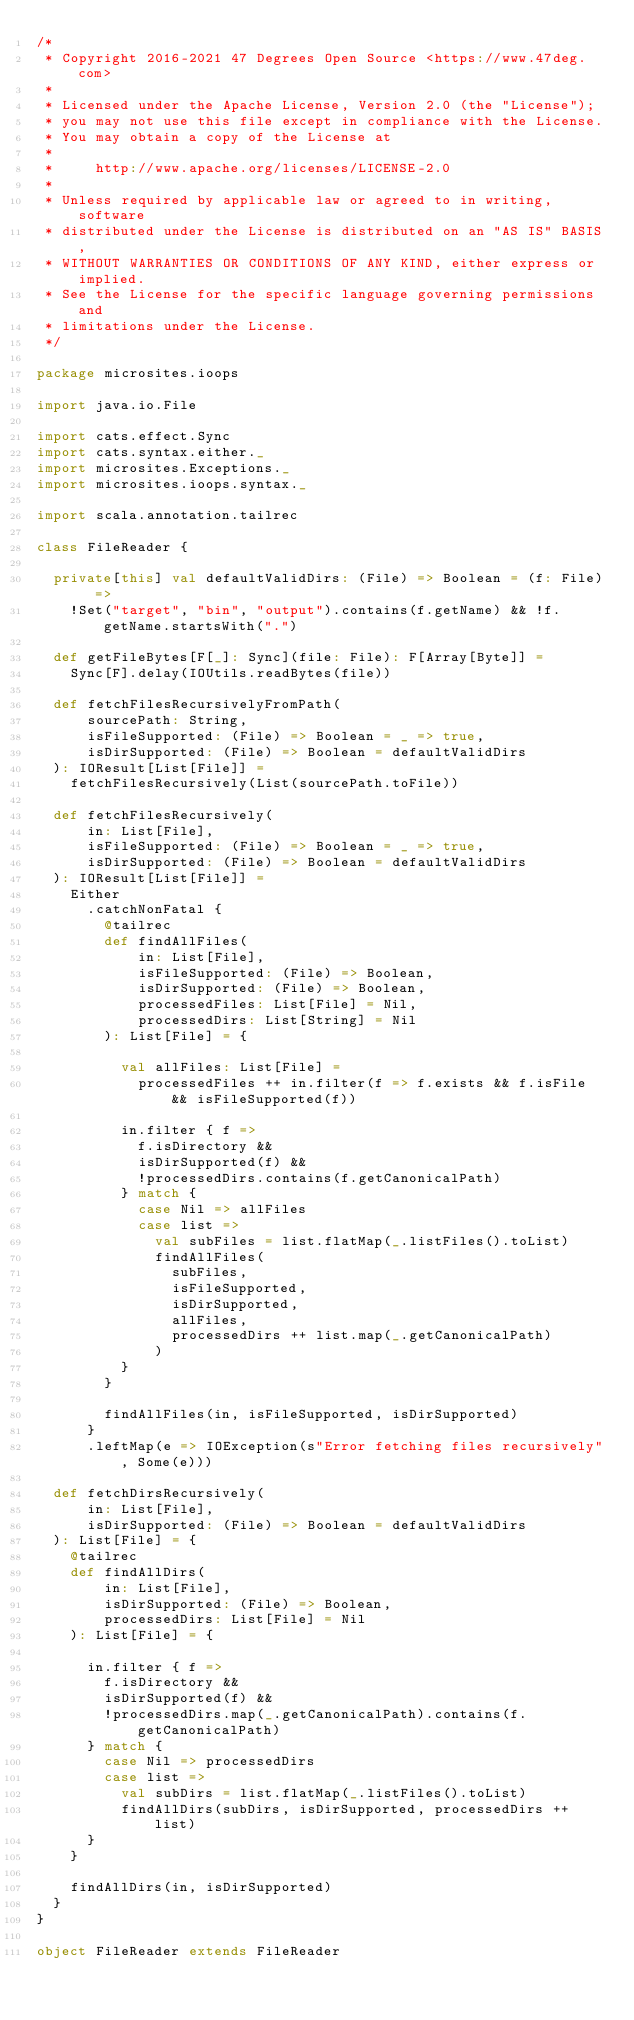Convert code to text. <code><loc_0><loc_0><loc_500><loc_500><_Scala_>/*
 * Copyright 2016-2021 47 Degrees Open Source <https://www.47deg.com>
 *
 * Licensed under the Apache License, Version 2.0 (the "License");
 * you may not use this file except in compliance with the License.
 * You may obtain a copy of the License at
 *
 *     http://www.apache.org/licenses/LICENSE-2.0
 *
 * Unless required by applicable law or agreed to in writing, software
 * distributed under the License is distributed on an "AS IS" BASIS,
 * WITHOUT WARRANTIES OR CONDITIONS OF ANY KIND, either express or implied.
 * See the License for the specific language governing permissions and
 * limitations under the License.
 */

package microsites.ioops

import java.io.File

import cats.effect.Sync
import cats.syntax.either._
import microsites.Exceptions._
import microsites.ioops.syntax._

import scala.annotation.tailrec

class FileReader {

  private[this] val defaultValidDirs: (File) => Boolean = (f: File) =>
    !Set("target", "bin", "output").contains(f.getName) && !f.getName.startsWith(".")

  def getFileBytes[F[_]: Sync](file: File): F[Array[Byte]] =
    Sync[F].delay(IOUtils.readBytes(file))

  def fetchFilesRecursivelyFromPath(
      sourcePath: String,
      isFileSupported: (File) => Boolean = _ => true,
      isDirSupported: (File) => Boolean = defaultValidDirs
  ): IOResult[List[File]] =
    fetchFilesRecursively(List(sourcePath.toFile))

  def fetchFilesRecursively(
      in: List[File],
      isFileSupported: (File) => Boolean = _ => true,
      isDirSupported: (File) => Boolean = defaultValidDirs
  ): IOResult[List[File]] =
    Either
      .catchNonFatal {
        @tailrec
        def findAllFiles(
            in: List[File],
            isFileSupported: (File) => Boolean,
            isDirSupported: (File) => Boolean,
            processedFiles: List[File] = Nil,
            processedDirs: List[String] = Nil
        ): List[File] = {

          val allFiles: List[File] =
            processedFiles ++ in.filter(f => f.exists && f.isFile && isFileSupported(f))

          in.filter { f =>
            f.isDirectory &&
            isDirSupported(f) &&
            !processedDirs.contains(f.getCanonicalPath)
          } match {
            case Nil => allFiles
            case list =>
              val subFiles = list.flatMap(_.listFiles().toList)
              findAllFiles(
                subFiles,
                isFileSupported,
                isDirSupported,
                allFiles,
                processedDirs ++ list.map(_.getCanonicalPath)
              )
          }
        }

        findAllFiles(in, isFileSupported, isDirSupported)
      }
      .leftMap(e => IOException(s"Error fetching files recursively", Some(e)))

  def fetchDirsRecursively(
      in: List[File],
      isDirSupported: (File) => Boolean = defaultValidDirs
  ): List[File] = {
    @tailrec
    def findAllDirs(
        in: List[File],
        isDirSupported: (File) => Boolean,
        processedDirs: List[File] = Nil
    ): List[File] = {

      in.filter { f =>
        f.isDirectory &&
        isDirSupported(f) &&
        !processedDirs.map(_.getCanonicalPath).contains(f.getCanonicalPath)
      } match {
        case Nil => processedDirs
        case list =>
          val subDirs = list.flatMap(_.listFiles().toList)
          findAllDirs(subDirs, isDirSupported, processedDirs ++ list)
      }
    }

    findAllDirs(in, isDirSupported)
  }
}

object FileReader extends FileReader
</code> 